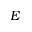<formula> <loc_0><loc_0><loc_500><loc_500>E</formula> 